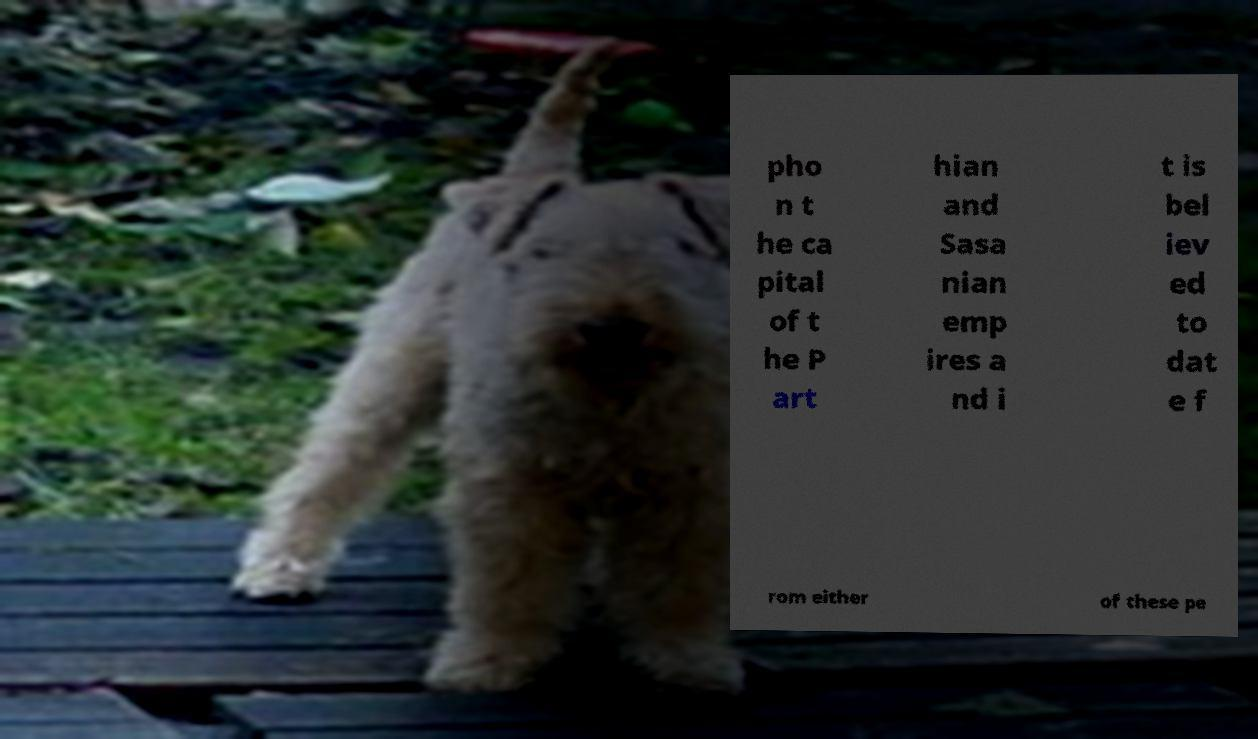I need the written content from this picture converted into text. Can you do that? pho n t he ca pital of t he P art hian and Sasa nian emp ires a nd i t is bel iev ed to dat e f rom either of these pe 